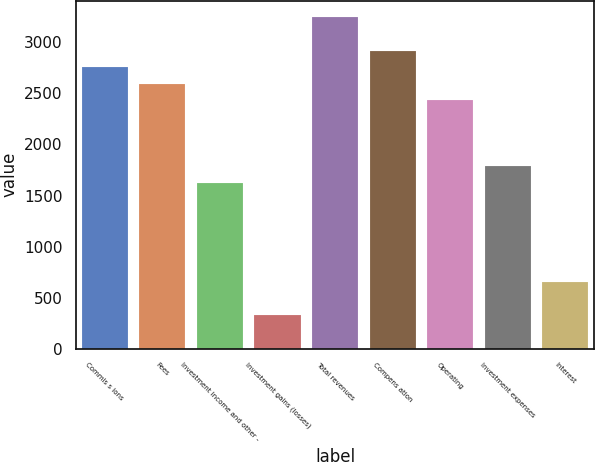Convert chart. <chart><loc_0><loc_0><loc_500><loc_500><bar_chart><fcel>Commis s ions<fcel>Fees<fcel>Investment income and other -<fcel>Investment gains (losses)<fcel>Total revenues<fcel>Compens ation<fcel>Operating<fcel>Investment expenses<fcel>Interest<nl><fcel>2758.81<fcel>2596.6<fcel>1623.34<fcel>325.66<fcel>3245.44<fcel>2921.02<fcel>2434.39<fcel>1785.55<fcel>650.08<nl></chart> 